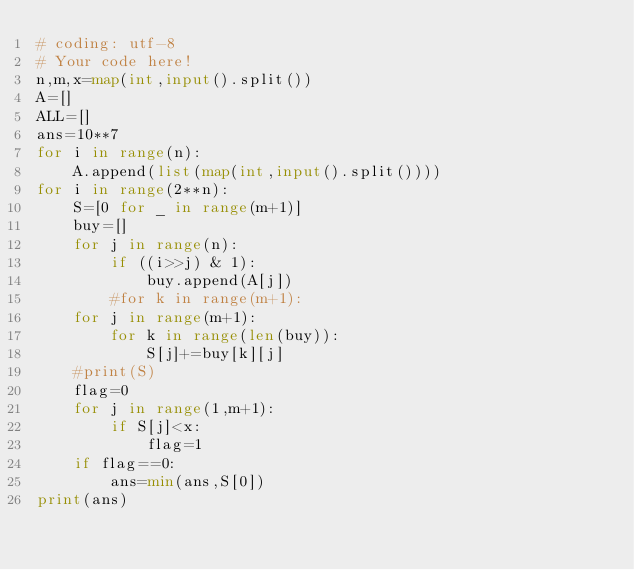Convert code to text. <code><loc_0><loc_0><loc_500><loc_500><_Python_># coding: utf-8
# Your code here!
n,m,x=map(int,input().split())
A=[]
ALL=[]
ans=10**7
for i in range(n):
    A.append(list(map(int,input().split())))
for i in range(2**n):
    S=[0 for _ in range(m+1)]
    buy=[]
    for j in range(n):
        if ((i>>j) & 1):
            buy.append(A[j])
        #for k in range(m+1):
    for j in range(m+1):
        for k in range(len(buy)):
            S[j]+=buy[k][j]
    #print(S)
    flag=0
    for j in range(1,m+1):
        if S[j]<x:
            flag=1
    if flag==0:
        ans=min(ans,S[0])
print(ans)</code> 